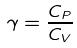Convert formula to latex. <formula><loc_0><loc_0><loc_500><loc_500>\gamma = \frac { C _ { P } } { C _ { V } }</formula> 